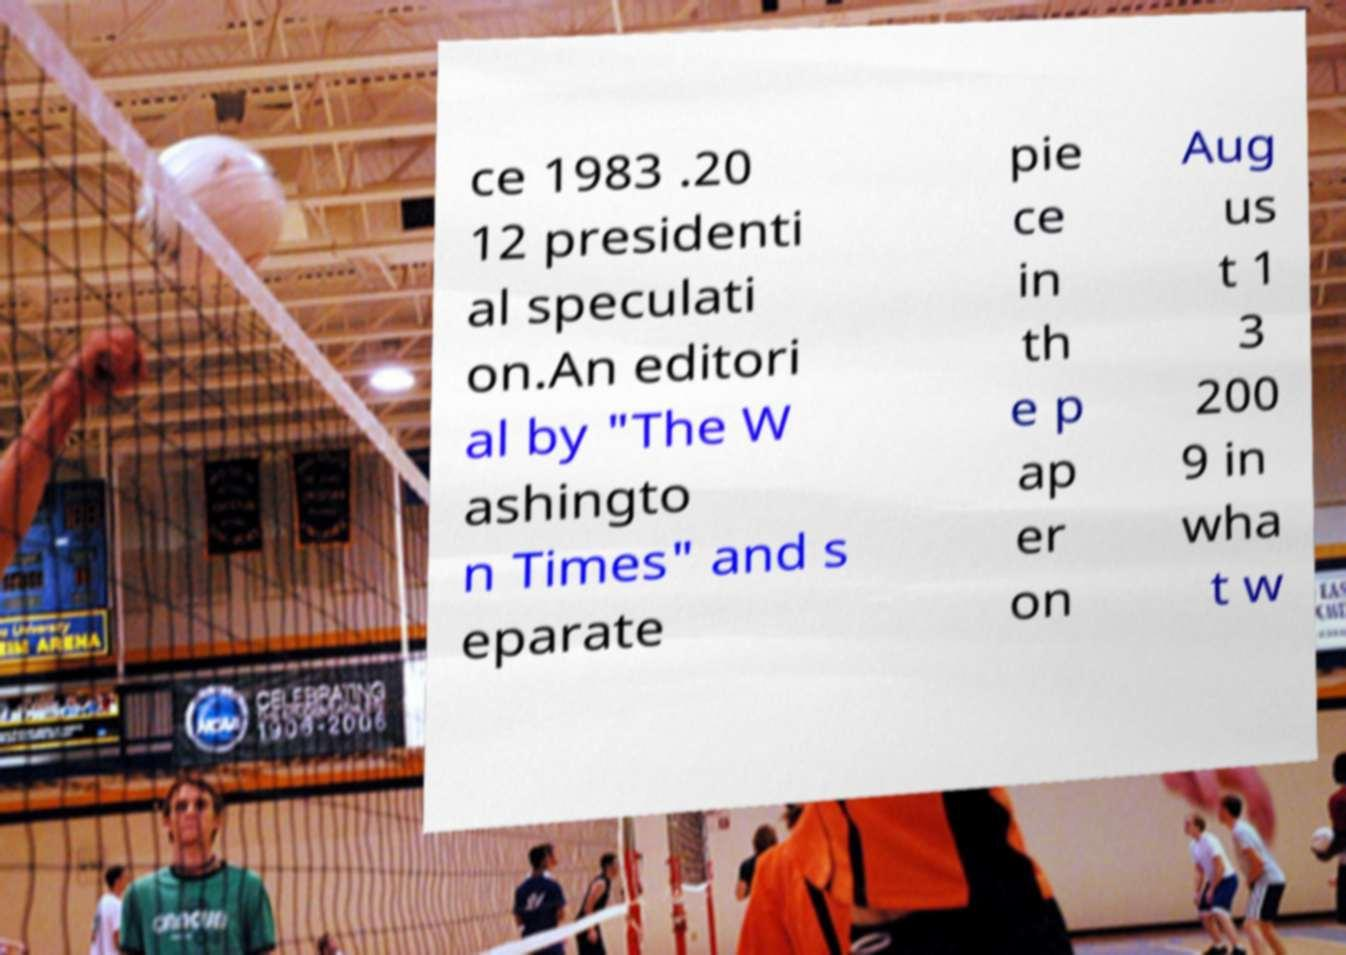For documentation purposes, I need the text within this image transcribed. Could you provide that? ce 1983 .20 12 presidenti al speculati on.An editori al by "The W ashingto n Times" and s eparate pie ce in th e p ap er on Aug us t 1 3 200 9 in wha t w 